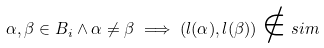<formula> <loc_0><loc_0><loc_500><loc_500>\alpha , \beta \in B _ { i } \wedge \alpha \not = \beta \implies ( l ( \alpha ) , l ( \beta ) ) \notin s i m</formula> 